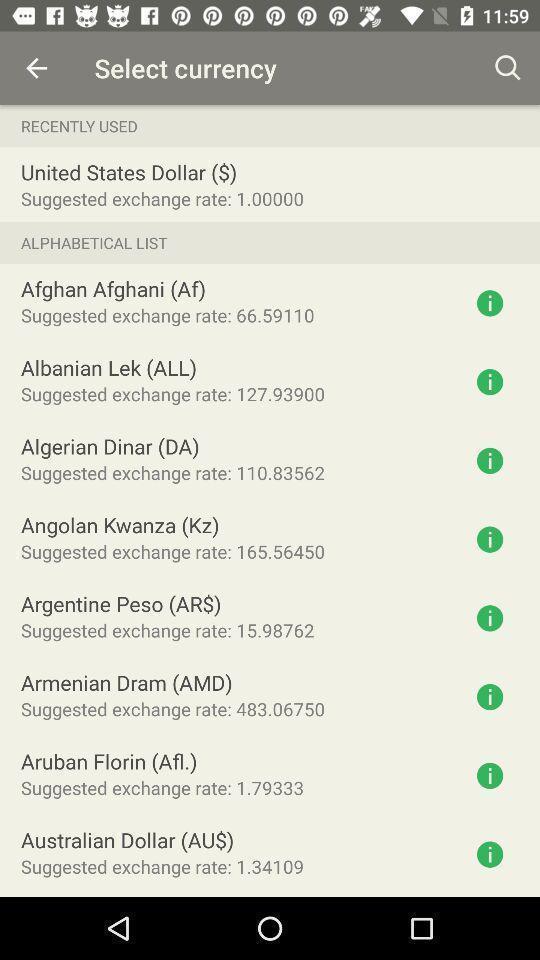Tell me about the visual elements in this screen capture. Screen showing to select a currency. 